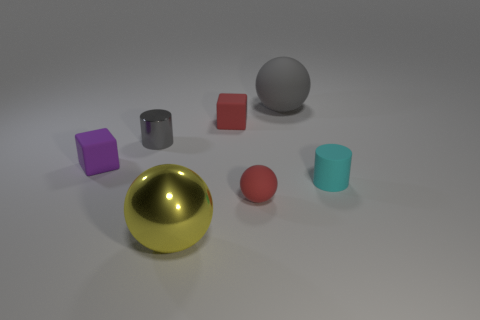The metal cylinder that is the same color as the large rubber thing is what size?
Offer a terse response. Small. Are there any green objects that have the same shape as the tiny purple rubber thing?
Offer a very short reply. No. There is a rubber thing that is the same color as the tiny sphere; what is its shape?
Your answer should be very brief. Cube. Are there any big yellow shiny objects behind the shiny object in front of the tiny cylinder on the right side of the big matte object?
Provide a succinct answer. No. What is the shape of the gray shiny object that is the same size as the red matte sphere?
Provide a succinct answer. Cylinder. What color is the big shiny thing that is the same shape as the big gray rubber thing?
Make the answer very short. Yellow. How many things are either yellow metallic objects or gray cylinders?
Your answer should be very brief. 2. There is a gray thing that is in front of the big rubber sphere; is it the same shape as the tiny thing to the right of the large gray rubber sphere?
Ensure brevity in your answer.  Yes. The red matte object that is behind the purple matte block has what shape?
Your answer should be very brief. Cube. Are there an equal number of small red spheres on the left side of the large yellow thing and small red rubber spheres that are in front of the red ball?
Your answer should be compact. Yes. 